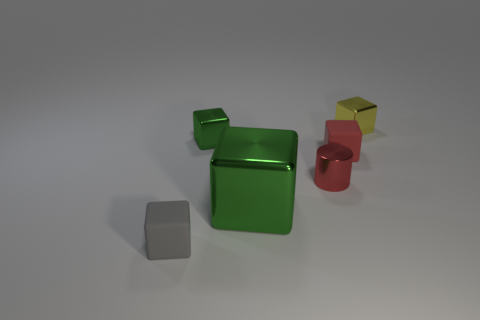Could the material of these objects influence their real-world application? Yes, the material properties such as hardness, texture, and weight would significantly affect their utility. For instance, if they are made of metal, they could be durable components for construction or machinery, while if they are made of plastic, they might be better suited as children's toys or educational aids. 